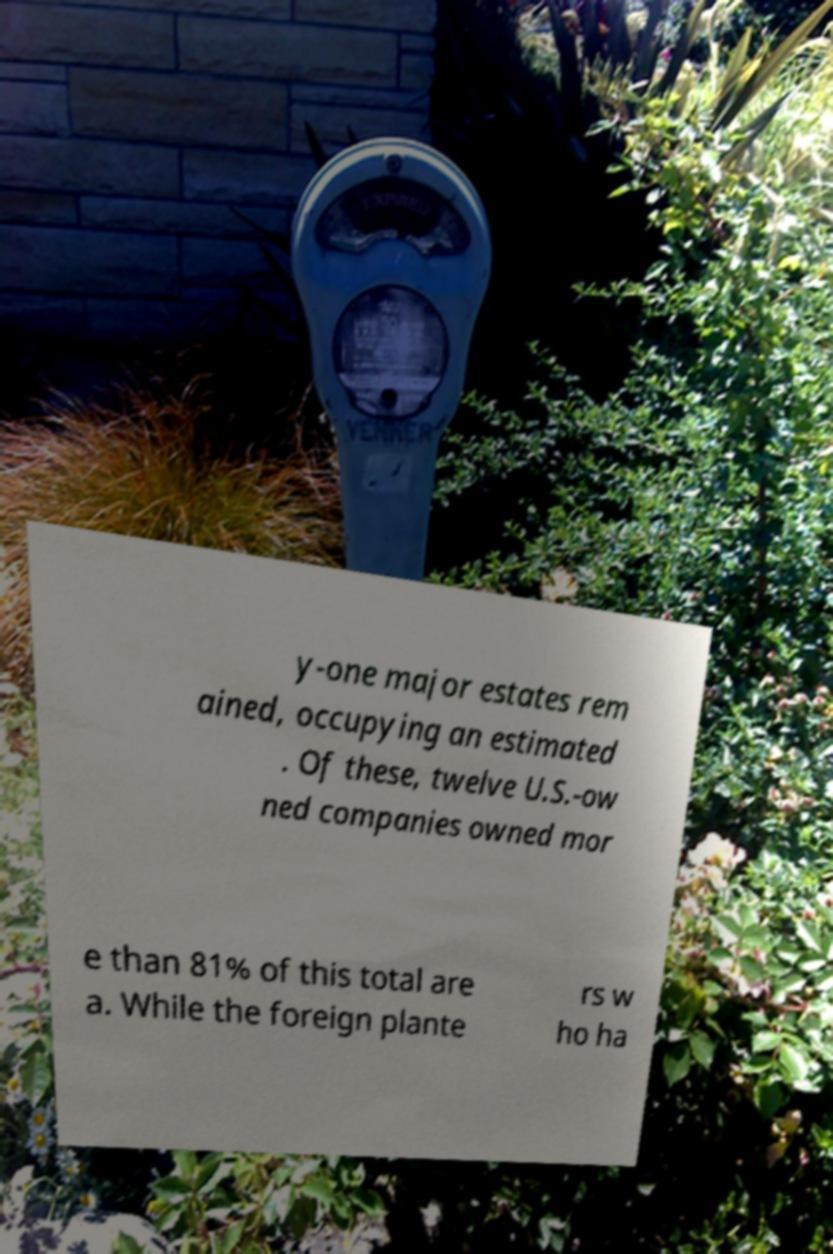There's text embedded in this image that I need extracted. Can you transcribe it verbatim? y-one major estates rem ained, occupying an estimated . Of these, twelve U.S.-ow ned companies owned mor e than 81% of this total are a. While the foreign plante rs w ho ha 